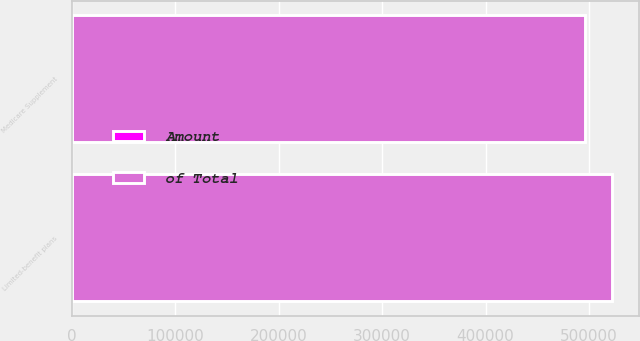<chart> <loc_0><loc_0><loc_500><loc_500><stacked_bar_chart><ecel><fcel>Medicare Supplement<fcel>Limited-benefit plans<nl><fcel>of Total<fcel>495982<fcel>522038<nl><fcel>Amount<fcel>49<fcel>51<nl></chart> 